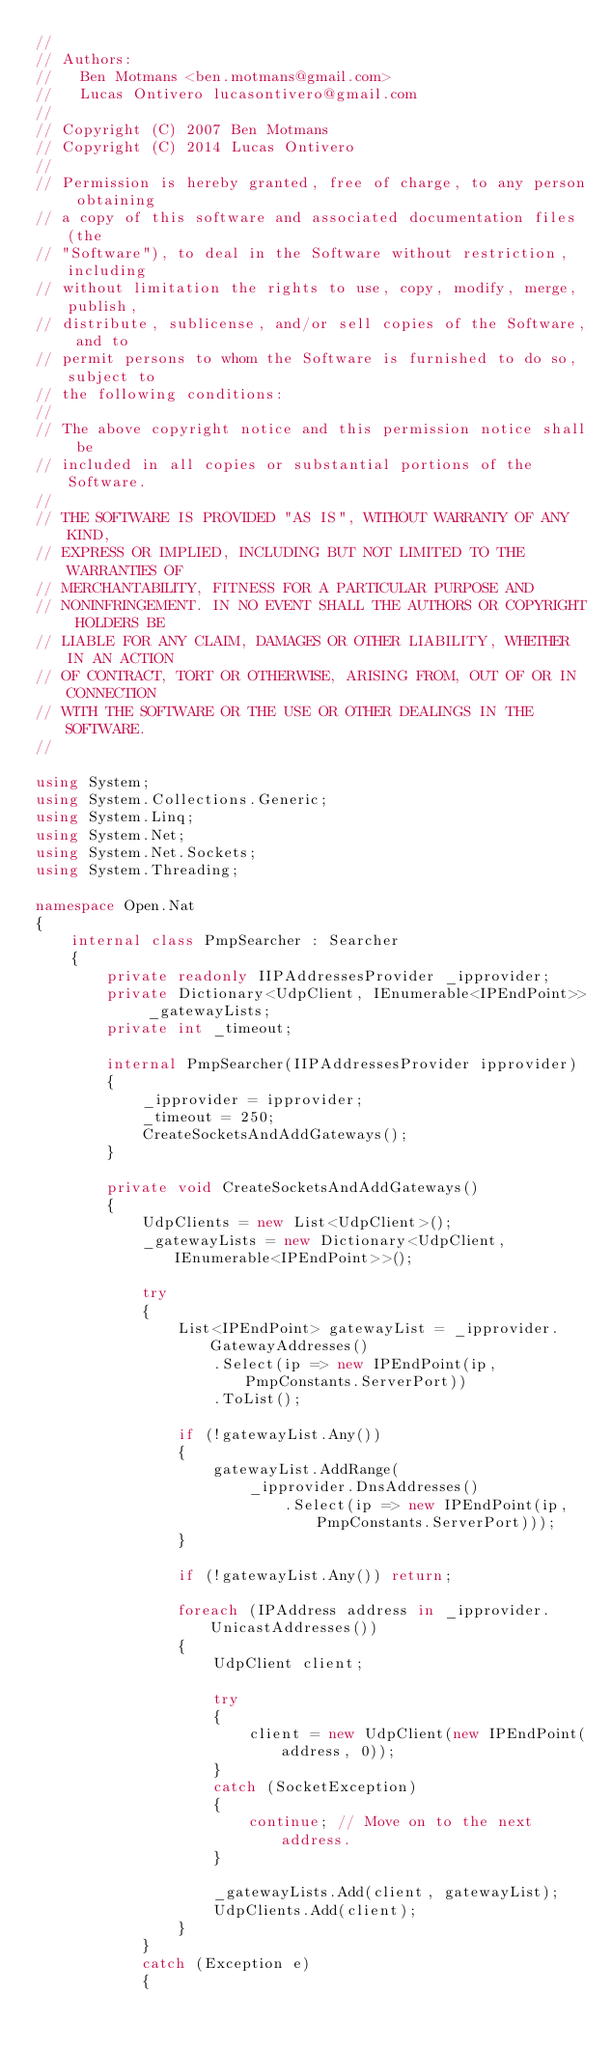<code> <loc_0><loc_0><loc_500><loc_500><_C#_>//
// Authors:
//   Ben Motmans <ben.motmans@gmail.com>
//   Lucas Ontivero lucasontivero@gmail.com
//
// Copyright (C) 2007 Ben Motmans
// Copyright (C) 2014 Lucas Ontivero
//
// Permission is hereby granted, free of charge, to any person obtaining
// a copy of this software and associated documentation files (the
// "Software"), to deal in the Software without restriction, including
// without limitation the rights to use, copy, modify, merge, publish,
// distribute, sublicense, and/or sell copies of the Software, and to
// permit persons to whom the Software is furnished to do so, subject to
// the following conditions:
// 
// The above copyright notice and this permission notice shall be
// included in all copies or substantial portions of the Software.
// 
// THE SOFTWARE IS PROVIDED "AS IS", WITHOUT WARRANTY OF ANY KIND,
// EXPRESS OR IMPLIED, INCLUDING BUT NOT LIMITED TO THE WARRANTIES OF
// MERCHANTABILITY, FITNESS FOR A PARTICULAR PURPOSE AND
// NONINFRINGEMENT. IN NO EVENT SHALL THE AUTHORS OR COPYRIGHT HOLDERS BE
// LIABLE FOR ANY CLAIM, DAMAGES OR OTHER LIABILITY, WHETHER IN AN ACTION
// OF CONTRACT, TORT OR OTHERWISE, ARISING FROM, OUT OF OR IN CONNECTION
// WITH THE SOFTWARE OR THE USE OR OTHER DEALINGS IN THE SOFTWARE.
//

using System;
using System.Collections.Generic;
using System.Linq;
using System.Net;
using System.Net.Sockets;
using System.Threading;

namespace Open.Nat
{
	internal class PmpSearcher : Searcher
	{
		private readonly IIPAddressesProvider _ipprovider;
		private Dictionary<UdpClient, IEnumerable<IPEndPoint>> _gatewayLists;
		private int _timeout;

		internal PmpSearcher(IIPAddressesProvider ipprovider)
		{
			_ipprovider = ipprovider;
			_timeout = 250;
			CreateSocketsAndAddGateways();
		}

		private void CreateSocketsAndAddGateways()
		{
			UdpClients = new List<UdpClient>();
			_gatewayLists = new Dictionary<UdpClient, IEnumerable<IPEndPoint>>();

			try
			{
				List<IPEndPoint> gatewayList = _ipprovider.GatewayAddresses()
					.Select(ip => new IPEndPoint(ip, PmpConstants.ServerPort))
					.ToList();

				if (!gatewayList.Any())
				{
					gatewayList.AddRange(
						_ipprovider.DnsAddresses()
							.Select(ip => new IPEndPoint(ip, PmpConstants.ServerPort)));
				}

				if (!gatewayList.Any()) return;

				foreach (IPAddress address in _ipprovider.UnicastAddresses())
				{
					UdpClient client;

					try
					{
						client = new UdpClient(new IPEndPoint(address, 0));
					}
					catch (SocketException)
					{
						continue; // Move on to the next address.
					}

					_gatewayLists.Add(client, gatewayList);
					UdpClients.Add(client);
				}
			}
			catch (Exception e)
			{</code> 